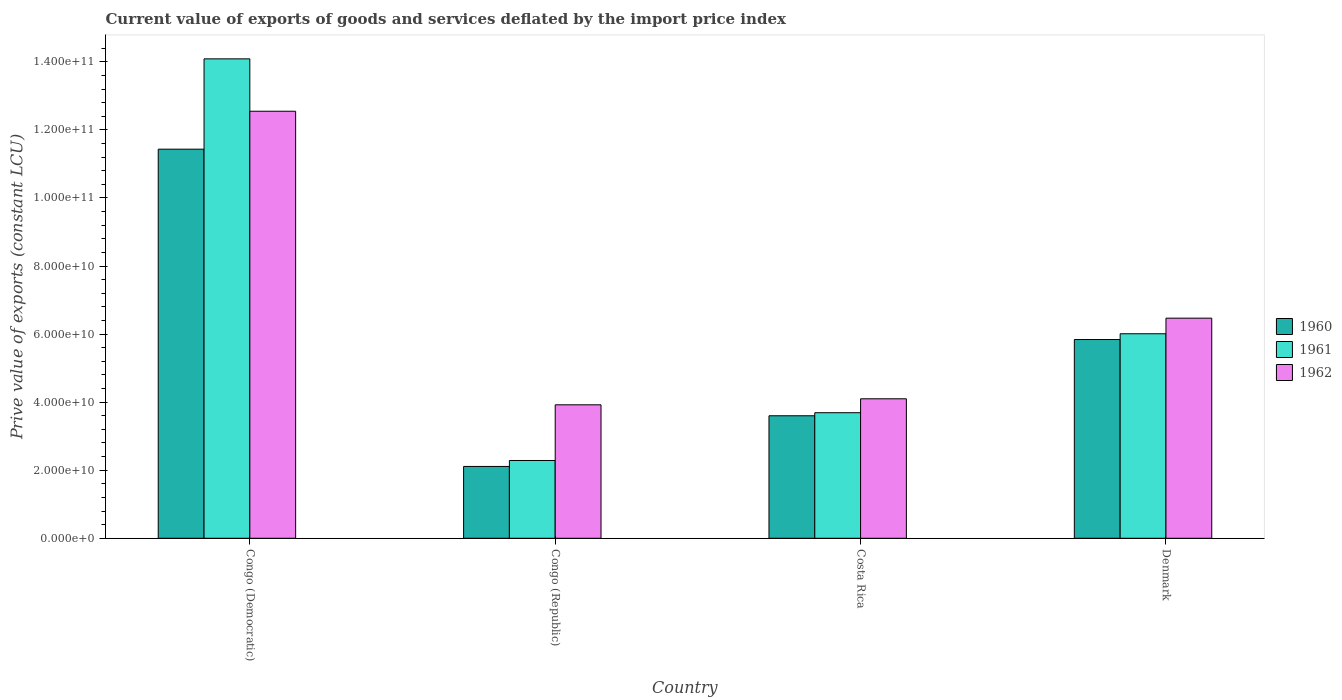How many different coloured bars are there?
Provide a succinct answer. 3. Are the number of bars on each tick of the X-axis equal?
Offer a very short reply. Yes. What is the label of the 1st group of bars from the left?
Offer a terse response. Congo (Democratic). In how many cases, is the number of bars for a given country not equal to the number of legend labels?
Offer a very short reply. 0. What is the prive value of exports in 1962 in Denmark?
Make the answer very short. 6.47e+1. Across all countries, what is the maximum prive value of exports in 1962?
Make the answer very short. 1.25e+11. Across all countries, what is the minimum prive value of exports in 1962?
Keep it short and to the point. 3.92e+1. In which country was the prive value of exports in 1960 maximum?
Keep it short and to the point. Congo (Democratic). In which country was the prive value of exports in 1960 minimum?
Your answer should be compact. Congo (Republic). What is the total prive value of exports in 1960 in the graph?
Your answer should be very brief. 2.30e+11. What is the difference between the prive value of exports in 1960 in Congo (Democratic) and that in Denmark?
Provide a succinct answer. 5.59e+1. What is the difference between the prive value of exports in 1961 in Costa Rica and the prive value of exports in 1962 in Congo (Republic)?
Keep it short and to the point. -2.32e+09. What is the average prive value of exports in 1960 per country?
Ensure brevity in your answer.  5.75e+1. What is the difference between the prive value of exports of/in 1962 and prive value of exports of/in 1960 in Denmark?
Ensure brevity in your answer.  6.28e+09. In how many countries, is the prive value of exports in 1962 greater than 84000000000 LCU?
Provide a succinct answer. 1. What is the ratio of the prive value of exports in 1962 in Costa Rica to that in Denmark?
Ensure brevity in your answer.  0.63. What is the difference between the highest and the second highest prive value of exports in 1961?
Make the answer very short. 8.08e+1. What is the difference between the highest and the lowest prive value of exports in 1961?
Provide a short and direct response. 1.18e+11. In how many countries, is the prive value of exports in 1960 greater than the average prive value of exports in 1960 taken over all countries?
Your response must be concise. 2. Is the sum of the prive value of exports in 1960 in Congo (Democratic) and Costa Rica greater than the maximum prive value of exports in 1962 across all countries?
Your response must be concise. Yes. What does the 2nd bar from the right in Costa Rica represents?
Ensure brevity in your answer.  1961. Is it the case that in every country, the sum of the prive value of exports in 1960 and prive value of exports in 1961 is greater than the prive value of exports in 1962?
Your response must be concise. Yes. How many bars are there?
Your answer should be compact. 12. Are all the bars in the graph horizontal?
Provide a short and direct response. No. How many countries are there in the graph?
Your answer should be compact. 4. What is the difference between two consecutive major ticks on the Y-axis?
Your response must be concise. 2.00e+1. Does the graph contain any zero values?
Your answer should be compact. No. Where does the legend appear in the graph?
Keep it short and to the point. Center right. How many legend labels are there?
Offer a terse response. 3. How are the legend labels stacked?
Ensure brevity in your answer.  Vertical. What is the title of the graph?
Offer a very short reply. Current value of exports of goods and services deflated by the import price index. What is the label or title of the X-axis?
Make the answer very short. Country. What is the label or title of the Y-axis?
Offer a terse response. Prive value of exports (constant LCU). What is the Prive value of exports (constant LCU) in 1960 in Congo (Democratic)?
Give a very brief answer. 1.14e+11. What is the Prive value of exports (constant LCU) of 1961 in Congo (Democratic)?
Offer a terse response. 1.41e+11. What is the Prive value of exports (constant LCU) in 1962 in Congo (Democratic)?
Provide a succinct answer. 1.25e+11. What is the Prive value of exports (constant LCU) of 1960 in Congo (Republic)?
Offer a terse response. 2.11e+1. What is the Prive value of exports (constant LCU) in 1961 in Congo (Republic)?
Provide a short and direct response. 2.29e+1. What is the Prive value of exports (constant LCU) of 1962 in Congo (Republic)?
Ensure brevity in your answer.  3.92e+1. What is the Prive value of exports (constant LCU) in 1960 in Costa Rica?
Your answer should be compact. 3.60e+1. What is the Prive value of exports (constant LCU) in 1961 in Costa Rica?
Your response must be concise. 3.69e+1. What is the Prive value of exports (constant LCU) in 1962 in Costa Rica?
Provide a short and direct response. 4.10e+1. What is the Prive value of exports (constant LCU) in 1960 in Denmark?
Offer a terse response. 5.84e+1. What is the Prive value of exports (constant LCU) in 1961 in Denmark?
Provide a short and direct response. 6.01e+1. What is the Prive value of exports (constant LCU) of 1962 in Denmark?
Your response must be concise. 6.47e+1. Across all countries, what is the maximum Prive value of exports (constant LCU) of 1960?
Give a very brief answer. 1.14e+11. Across all countries, what is the maximum Prive value of exports (constant LCU) in 1961?
Ensure brevity in your answer.  1.41e+11. Across all countries, what is the maximum Prive value of exports (constant LCU) of 1962?
Make the answer very short. 1.25e+11. Across all countries, what is the minimum Prive value of exports (constant LCU) of 1960?
Offer a terse response. 2.11e+1. Across all countries, what is the minimum Prive value of exports (constant LCU) of 1961?
Give a very brief answer. 2.29e+1. Across all countries, what is the minimum Prive value of exports (constant LCU) of 1962?
Your answer should be compact. 3.92e+1. What is the total Prive value of exports (constant LCU) of 1960 in the graph?
Keep it short and to the point. 2.30e+11. What is the total Prive value of exports (constant LCU) of 1961 in the graph?
Give a very brief answer. 2.61e+11. What is the total Prive value of exports (constant LCU) in 1962 in the graph?
Ensure brevity in your answer.  2.70e+11. What is the difference between the Prive value of exports (constant LCU) in 1960 in Congo (Democratic) and that in Congo (Republic)?
Ensure brevity in your answer.  9.32e+1. What is the difference between the Prive value of exports (constant LCU) of 1961 in Congo (Democratic) and that in Congo (Republic)?
Give a very brief answer. 1.18e+11. What is the difference between the Prive value of exports (constant LCU) in 1962 in Congo (Democratic) and that in Congo (Republic)?
Your answer should be very brief. 8.63e+1. What is the difference between the Prive value of exports (constant LCU) of 1960 in Congo (Democratic) and that in Costa Rica?
Your answer should be compact. 7.83e+1. What is the difference between the Prive value of exports (constant LCU) of 1961 in Congo (Democratic) and that in Costa Rica?
Offer a terse response. 1.04e+11. What is the difference between the Prive value of exports (constant LCU) in 1962 in Congo (Democratic) and that in Costa Rica?
Keep it short and to the point. 8.45e+1. What is the difference between the Prive value of exports (constant LCU) of 1960 in Congo (Democratic) and that in Denmark?
Keep it short and to the point. 5.59e+1. What is the difference between the Prive value of exports (constant LCU) of 1961 in Congo (Democratic) and that in Denmark?
Give a very brief answer. 8.08e+1. What is the difference between the Prive value of exports (constant LCU) in 1962 in Congo (Democratic) and that in Denmark?
Provide a short and direct response. 6.08e+1. What is the difference between the Prive value of exports (constant LCU) in 1960 in Congo (Republic) and that in Costa Rica?
Your response must be concise. -1.49e+1. What is the difference between the Prive value of exports (constant LCU) in 1961 in Congo (Republic) and that in Costa Rica?
Your answer should be very brief. -1.40e+1. What is the difference between the Prive value of exports (constant LCU) of 1962 in Congo (Republic) and that in Costa Rica?
Your answer should be very brief. -1.77e+09. What is the difference between the Prive value of exports (constant LCU) in 1960 in Congo (Republic) and that in Denmark?
Give a very brief answer. -3.73e+1. What is the difference between the Prive value of exports (constant LCU) of 1961 in Congo (Republic) and that in Denmark?
Provide a succinct answer. -3.72e+1. What is the difference between the Prive value of exports (constant LCU) of 1962 in Congo (Republic) and that in Denmark?
Your response must be concise. -2.55e+1. What is the difference between the Prive value of exports (constant LCU) in 1960 in Costa Rica and that in Denmark?
Offer a terse response. -2.24e+1. What is the difference between the Prive value of exports (constant LCU) in 1961 in Costa Rica and that in Denmark?
Your answer should be compact. -2.32e+1. What is the difference between the Prive value of exports (constant LCU) of 1962 in Costa Rica and that in Denmark?
Ensure brevity in your answer.  -2.37e+1. What is the difference between the Prive value of exports (constant LCU) of 1960 in Congo (Democratic) and the Prive value of exports (constant LCU) of 1961 in Congo (Republic)?
Offer a very short reply. 9.15e+1. What is the difference between the Prive value of exports (constant LCU) in 1960 in Congo (Democratic) and the Prive value of exports (constant LCU) in 1962 in Congo (Republic)?
Provide a succinct answer. 7.51e+1. What is the difference between the Prive value of exports (constant LCU) of 1961 in Congo (Democratic) and the Prive value of exports (constant LCU) of 1962 in Congo (Republic)?
Your answer should be very brief. 1.02e+11. What is the difference between the Prive value of exports (constant LCU) of 1960 in Congo (Democratic) and the Prive value of exports (constant LCU) of 1961 in Costa Rica?
Provide a succinct answer. 7.74e+1. What is the difference between the Prive value of exports (constant LCU) in 1960 in Congo (Democratic) and the Prive value of exports (constant LCU) in 1962 in Costa Rica?
Make the answer very short. 7.33e+1. What is the difference between the Prive value of exports (constant LCU) in 1961 in Congo (Democratic) and the Prive value of exports (constant LCU) in 1962 in Costa Rica?
Keep it short and to the point. 9.99e+1. What is the difference between the Prive value of exports (constant LCU) of 1960 in Congo (Democratic) and the Prive value of exports (constant LCU) of 1961 in Denmark?
Your answer should be very brief. 5.42e+1. What is the difference between the Prive value of exports (constant LCU) of 1960 in Congo (Democratic) and the Prive value of exports (constant LCU) of 1962 in Denmark?
Provide a succinct answer. 4.97e+1. What is the difference between the Prive value of exports (constant LCU) in 1961 in Congo (Democratic) and the Prive value of exports (constant LCU) in 1962 in Denmark?
Offer a terse response. 7.62e+1. What is the difference between the Prive value of exports (constant LCU) in 1960 in Congo (Republic) and the Prive value of exports (constant LCU) in 1961 in Costa Rica?
Keep it short and to the point. -1.58e+1. What is the difference between the Prive value of exports (constant LCU) in 1960 in Congo (Republic) and the Prive value of exports (constant LCU) in 1962 in Costa Rica?
Provide a succinct answer. -1.99e+1. What is the difference between the Prive value of exports (constant LCU) of 1961 in Congo (Republic) and the Prive value of exports (constant LCU) of 1962 in Costa Rica?
Give a very brief answer. -1.81e+1. What is the difference between the Prive value of exports (constant LCU) in 1960 in Congo (Republic) and the Prive value of exports (constant LCU) in 1961 in Denmark?
Provide a short and direct response. -3.90e+1. What is the difference between the Prive value of exports (constant LCU) in 1960 in Congo (Republic) and the Prive value of exports (constant LCU) in 1962 in Denmark?
Provide a succinct answer. -4.36e+1. What is the difference between the Prive value of exports (constant LCU) of 1961 in Congo (Republic) and the Prive value of exports (constant LCU) of 1962 in Denmark?
Give a very brief answer. -4.18e+1. What is the difference between the Prive value of exports (constant LCU) in 1960 in Costa Rica and the Prive value of exports (constant LCU) in 1961 in Denmark?
Provide a succinct answer. -2.41e+1. What is the difference between the Prive value of exports (constant LCU) of 1960 in Costa Rica and the Prive value of exports (constant LCU) of 1962 in Denmark?
Provide a succinct answer. -2.87e+1. What is the difference between the Prive value of exports (constant LCU) of 1961 in Costa Rica and the Prive value of exports (constant LCU) of 1962 in Denmark?
Your answer should be very brief. -2.78e+1. What is the average Prive value of exports (constant LCU) in 1960 per country?
Offer a terse response. 5.75e+1. What is the average Prive value of exports (constant LCU) of 1961 per country?
Your answer should be compact. 6.52e+1. What is the average Prive value of exports (constant LCU) in 1962 per country?
Your answer should be very brief. 6.76e+1. What is the difference between the Prive value of exports (constant LCU) in 1960 and Prive value of exports (constant LCU) in 1961 in Congo (Democratic)?
Ensure brevity in your answer.  -2.65e+1. What is the difference between the Prive value of exports (constant LCU) of 1960 and Prive value of exports (constant LCU) of 1962 in Congo (Democratic)?
Give a very brief answer. -1.11e+1. What is the difference between the Prive value of exports (constant LCU) of 1961 and Prive value of exports (constant LCU) of 1962 in Congo (Democratic)?
Offer a terse response. 1.54e+1. What is the difference between the Prive value of exports (constant LCU) in 1960 and Prive value of exports (constant LCU) in 1961 in Congo (Republic)?
Your answer should be very brief. -1.75e+09. What is the difference between the Prive value of exports (constant LCU) of 1960 and Prive value of exports (constant LCU) of 1962 in Congo (Republic)?
Provide a short and direct response. -1.81e+1. What is the difference between the Prive value of exports (constant LCU) in 1961 and Prive value of exports (constant LCU) in 1962 in Congo (Republic)?
Make the answer very short. -1.64e+1. What is the difference between the Prive value of exports (constant LCU) in 1960 and Prive value of exports (constant LCU) in 1961 in Costa Rica?
Your response must be concise. -8.99e+08. What is the difference between the Prive value of exports (constant LCU) in 1960 and Prive value of exports (constant LCU) in 1962 in Costa Rica?
Offer a terse response. -4.99e+09. What is the difference between the Prive value of exports (constant LCU) of 1961 and Prive value of exports (constant LCU) of 1962 in Costa Rica?
Provide a short and direct response. -4.09e+09. What is the difference between the Prive value of exports (constant LCU) in 1960 and Prive value of exports (constant LCU) in 1961 in Denmark?
Offer a terse response. -1.70e+09. What is the difference between the Prive value of exports (constant LCU) in 1960 and Prive value of exports (constant LCU) in 1962 in Denmark?
Your answer should be compact. -6.28e+09. What is the difference between the Prive value of exports (constant LCU) of 1961 and Prive value of exports (constant LCU) of 1962 in Denmark?
Your answer should be very brief. -4.58e+09. What is the ratio of the Prive value of exports (constant LCU) of 1960 in Congo (Democratic) to that in Congo (Republic)?
Keep it short and to the point. 5.42. What is the ratio of the Prive value of exports (constant LCU) in 1961 in Congo (Democratic) to that in Congo (Republic)?
Keep it short and to the point. 6.16. What is the ratio of the Prive value of exports (constant LCU) in 1962 in Congo (Democratic) to that in Congo (Republic)?
Provide a succinct answer. 3.2. What is the ratio of the Prive value of exports (constant LCU) in 1960 in Congo (Democratic) to that in Costa Rica?
Your response must be concise. 3.18. What is the ratio of the Prive value of exports (constant LCU) in 1961 in Congo (Democratic) to that in Costa Rica?
Your answer should be compact. 3.82. What is the ratio of the Prive value of exports (constant LCU) in 1962 in Congo (Democratic) to that in Costa Rica?
Provide a short and direct response. 3.06. What is the ratio of the Prive value of exports (constant LCU) of 1960 in Congo (Democratic) to that in Denmark?
Offer a very short reply. 1.96. What is the ratio of the Prive value of exports (constant LCU) of 1961 in Congo (Democratic) to that in Denmark?
Provide a short and direct response. 2.34. What is the ratio of the Prive value of exports (constant LCU) of 1962 in Congo (Democratic) to that in Denmark?
Your response must be concise. 1.94. What is the ratio of the Prive value of exports (constant LCU) of 1960 in Congo (Republic) to that in Costa Rica?
Your response must be concise. 0.59. What is the ratio of the Prive value of exports (constant LCU) in 1961 in Congo (Republic) to that in Costa Rica?
Give a very brief answer. 0.62. What is the ratio of the Prive value of exports (constant LCU) of 1962 in Congo (Republic) to that in Costa Rica?
Ensure brevity in your answer.  0.96. What is the ratio of the Prive value of exports (constant LCU) in 1960 in Congo (Republic) to that in Denmark?
Offer a very short reply. 0.36. What is the ratio of the Prive value of exports (constant LCU) of 1961 in Congo (Republic) to that in Denmark?
Provide a short and direct response. 0.38. What is the ratio of the Prive value of exports (constant LCU) of 1962 in Congo (Republic) to that in Denmark?
Your answer should be compact. 0.61. What is the ratio of the Prive value of exports (constant LCU) in 1960 in Costa Rica to that in Denmark?
Make the answer very short. 0.62. What is the ratio of the Prive value of exports (constant LCU) in 1961 in Costa Rica to that in Denmark?
Your response must be concise. 0.61. What is the ratio of the Prive value of exports (constant LCU) in 1962 in Costa Rica to that in Denmark?
Your answer should be very brief. 0.63. What is the difference between the highest and the second highest Prive value of exports (constant LCU) of 1960?
Give a very brief answer. 5.59e+1. What is the difference between the highest and the second highest Prive value of exports (constant LCU) of 1961?
Give a very brief answer. 8.08e+1. What is the difference between the highest and the second highest Prive value of exports (constant LCU) in 1962?
Ensure brevity in your answer.  6.08e+1. What is the difference between the highest and the lowest Prive value of exports (constant LCU) of 1960?
Provide a short and direct response. 9.32e+1. What is the difference between the highest and the lowest Prive value of exports (constant LCU) of 1961?
Your response must be concise. 1.18e+11. What is the difference between the highest and the lowest Prive value of exports (constant LCU) in 1962?
Your response must be concise. 8.63e+1. 